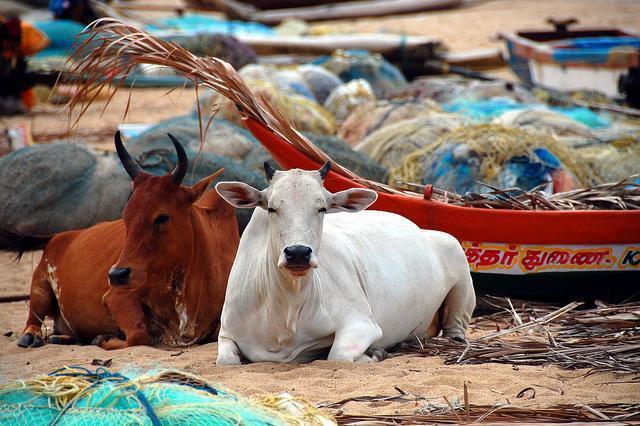What animal has similar things on their head to these animals?
Select the accurate response from the four choices given to answer the question.
Options: Skunk, cat, dog, goat. Goat. 